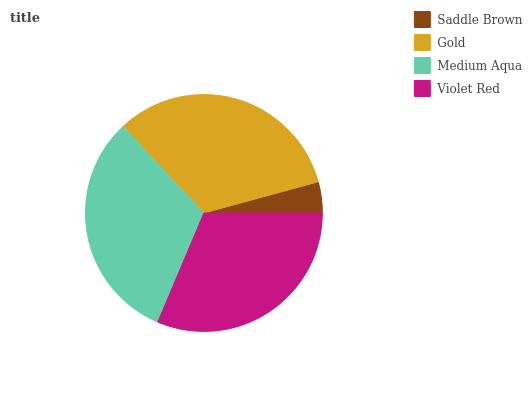Is Saddle Brown the minimum?
Answer yes or no. Yes. Is Gold the maximum?
Answer yes or no. Yes. Is Medium Aqua the minimum?
Answer yes or no. No. Is Medium Aqua the maximum?
Answer yes or no. No. Is Gold greater than Medium Aqua?
Answer yes or no. Yes. Is Medium Aqua less than Gold?
Answer yes or no. Yes. Is Medium Aqua greater than Gold?
Answer yes or no. No. Is Gold less than Medium Aqua?
Answer yes or no. No. Is Medium Aqua the high median?
Answer yes or no. Yes. Is Violet Red the low median?
Answer yes or no. Yes. Is Gold the high median?
Answer yes or no. No. Is Gold the low median?
Answer yes or no. No. 